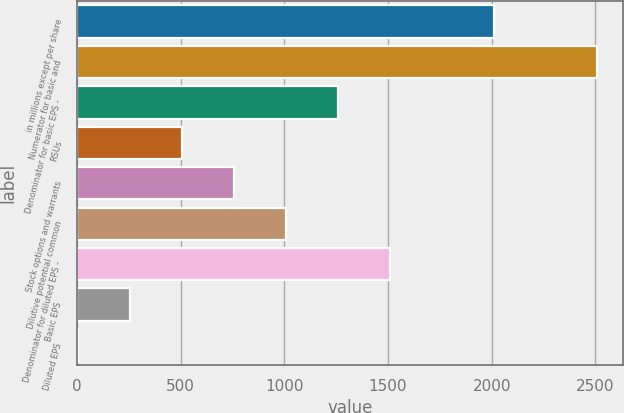<chart> <loc_0><loc_0><loc_500><loc_500><bar_chart><fcel>in millions except per share<fcel>Numerator for basic and<fcel>Denominator for basic EPS -<fcel>RSUs<fcel>Stock options and warrants<fcel>Dilutive potential common<fcel>Denominator for diluted EPS -<fcel>Basic EPS<fcel>Diluted EPS<nl><fcel>2011<fcel>2510<fcel>1257.26<fcel>505.61<fcel>756.16<fcel>1006.71<fcel>1507.81<fcel>255.06<fcel>4.51<nl></chart> 